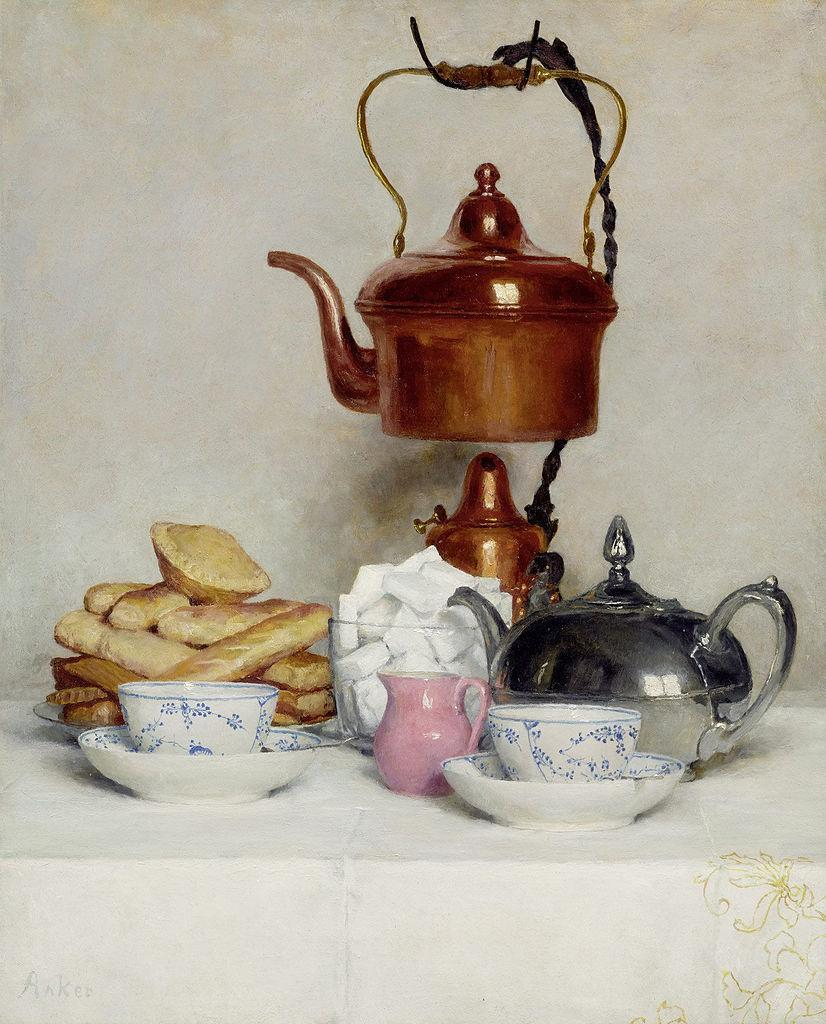What piece of furniture is present in the image? There is a table in the image. What can be found on the table? There are two cups and mugs on the table. Are there any other items on the table besides cups and mugs? Yes, there are other unspecified things on the table. How does the table show respect to the cups and mugs in the image? The table does not show respect to the cups and mugs; it is an inanimate object that simply holds them. 